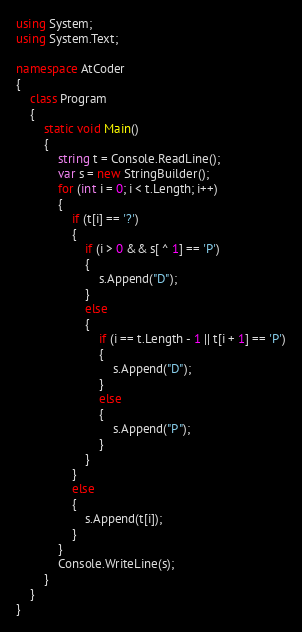Convert code to text. <code><loc_0><loc_0><loc_500><loc_500><_C#_>using System;
using System.Text;

namespace AtCoder
{
    class Program
    {
        static void Main()
        {
            string t = Console.ReadLine();
            var s = new StringBuilder();
            for (int i = 0; i < t.Length; i++)
            {
                if (t[i] == '?')
                {
                    if (i > 0 && s[ ^ 1] == 'P')
                    {
                        s.Append("D");
                    }
                    else
                    {
                        if (i == t.Length - 1 || t[i + 1] == 'P')
                        {
                            s.Append("D");
                        }
                        else
                        {
                            s.Append("P");
                        }
                    }
                }
                else
                {
                    s.Append(t[i]);
                }
            }
            Console.WriteLine(s);
        }
    }
}</code> 